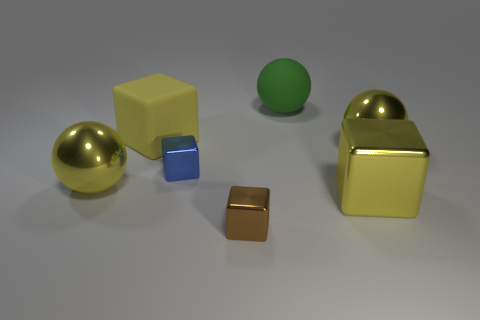Add 1 large green matte things. How many objects exist? 8 Subtract all balls. How many objects are left? 4 Add 3 small blue objects. How many small blue objects exist? 4 Subtract 0 green cylinders. How many objects are left? 7 Subtract all tiny metallic blocks. Subtract all tiny yellow blocks. How many objects are left? 5 Add 5 blue blocks. How many blue blocks are left? 6 